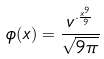<formula> <loc_0><loc_0><loc_500><loc_500>\phi ( x ) = \frac { v ^ { \cdot \frac { x ^ { 9 } } { 9 } } } { \sqrt { 9 \pi } }</formula> 